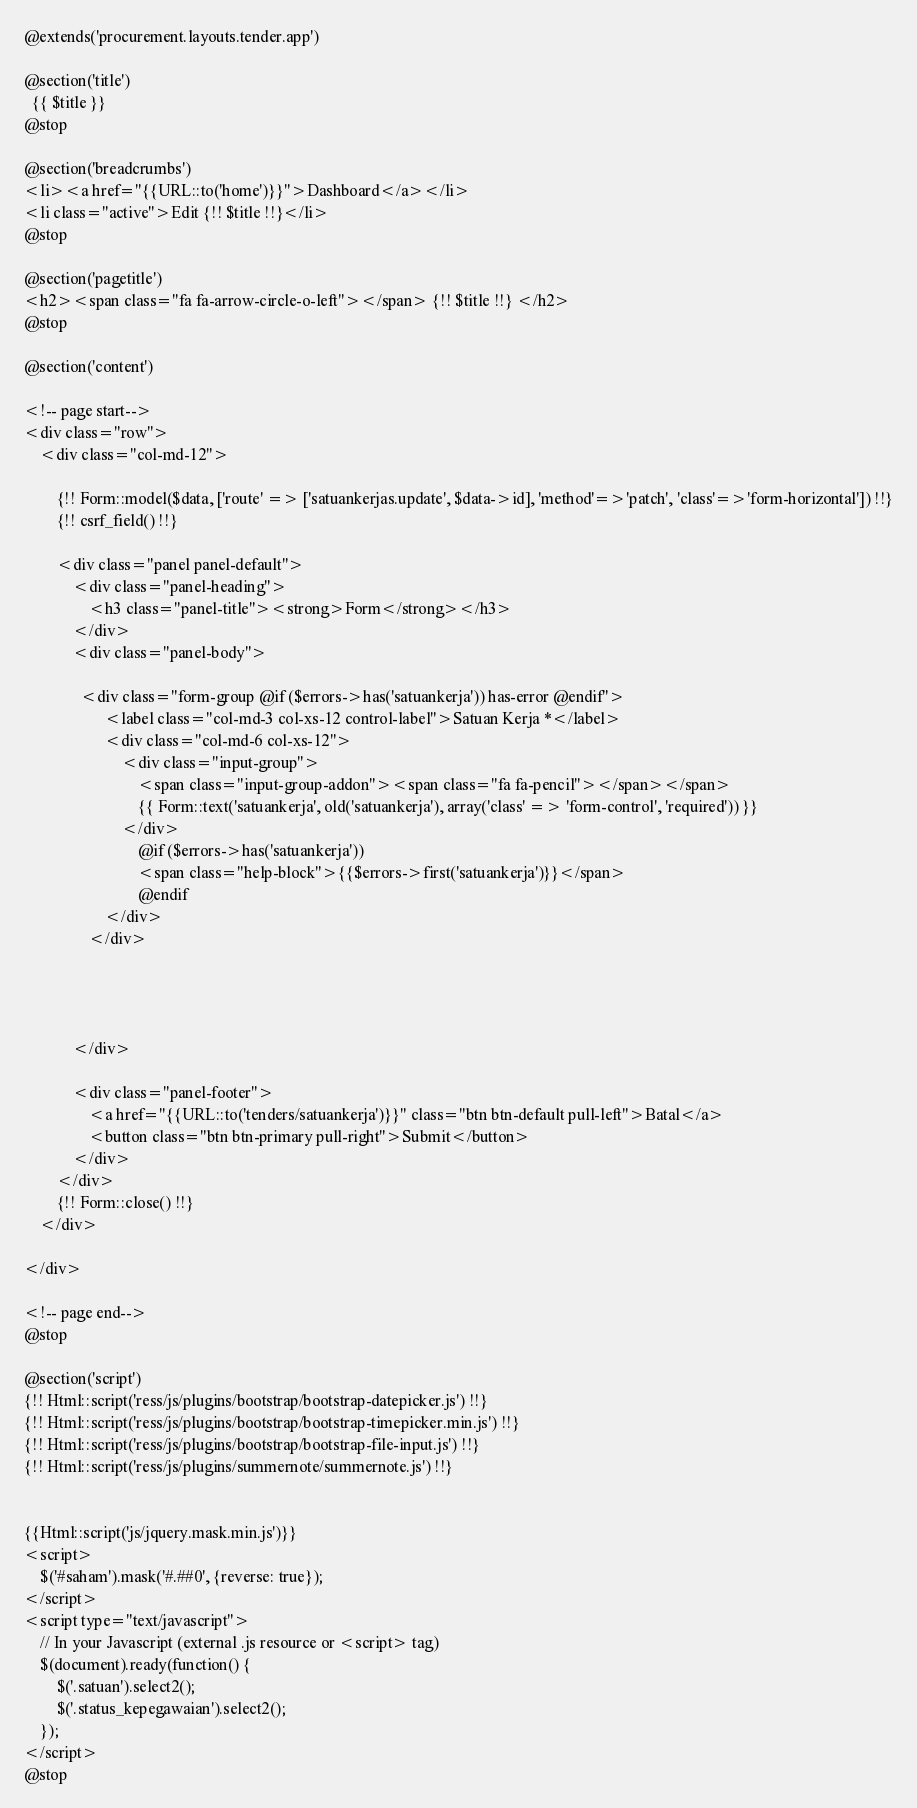Convert code to text. <code><loc_0><loc_0><loc_500><loc_500><_PHP_>@extends('procurement.layouts.tender.app')

@section('title')
  {{ $title }}
@stop

@section('breadcrumbs')
<li><a href="{{URL::to('home')}}">Dashboard</a></li>
<li class="active">Edit {!! $title !!}</li>
@stop

@section('pagetitle')
<h2><span class="fa fa-arrow-circle-o-left"></span> {!! $title !!} </h2>
@stop

@section('content')

<!-- page start-->
<div class="row">
    <div class="col-md-12">

        {!! Form::model($data, ['route' => ['satuankerjas.update', $data->id], 'method'=>'patch', 'class'=>'form-horizontal']) !!}
        {!! csrf_field() !!}

        <div class="panel panel-default">
            <div class="panel-heading">
                <h3 class="panel-title"><strong>Form</strong></h3>
            </div>
            <div class="panel-body">
                
              <div class="form-group @if ($errors->has('satuankerja')) has-error @endif">
                    <label class="col-md-3 col-xs-12 control-label">Satuan Kerja *</label>
                    <div class="col-md-6 col-xs-12">                                            
                        <div class="input-group">
                            <span class="input-group-addon"><span class="fa fa-pencil"></span></span>
                            {{ Form::text('satuankerja', old('satuankerja'), array('class' => 'form-control', 'required')) }}
                        </div>  
                            @if ($errors->has('satuankerja'))
                            <span class="help-block">{{$errors->first('satuankerja')}}</span>
                            @endif                                          
                    </div>
                </div>

               
   
                
            </div>
            
            <div class="panel-footer">     
                <a href="{{URL::to('tenders/satuankerja')}}" class="btn btn-default pull-left">Batal</a>                               
                <button class="btn btn-primary pull-right">Submit</button>
            </div>
        </div>
        {!! Form::close() !!}
    </div>
    
</div>

<!-- page end-->
@stop

@section('script')
{!! Html::script('ress/js/plugins/bootstrap/bootstrap-datepicker.js') !!}
{!! Html::script('ress/js/plugins/bootstrap/bootstrap-timepicker.min.js') !!}
{!! Html::script('ress/js/plugins/bootstrap/bootstrap-file-input.js') !!}
{!! Html::script('ress/js/plugins/summernote/summernote.js') !!}


{{Html::script('js/jquery.mask.min.js')}}
<script>
	$('#saham').mask('#.##0', {reverse: true});
</script>
<script type="text/javascript">
    // In your Javascript (external .js resource or <script> tag)
    $(document).ready(function() {
        $('.satuan').select2();
        $('.status_kepegawaian').select2();
    });
</script>
@stop
</code> 